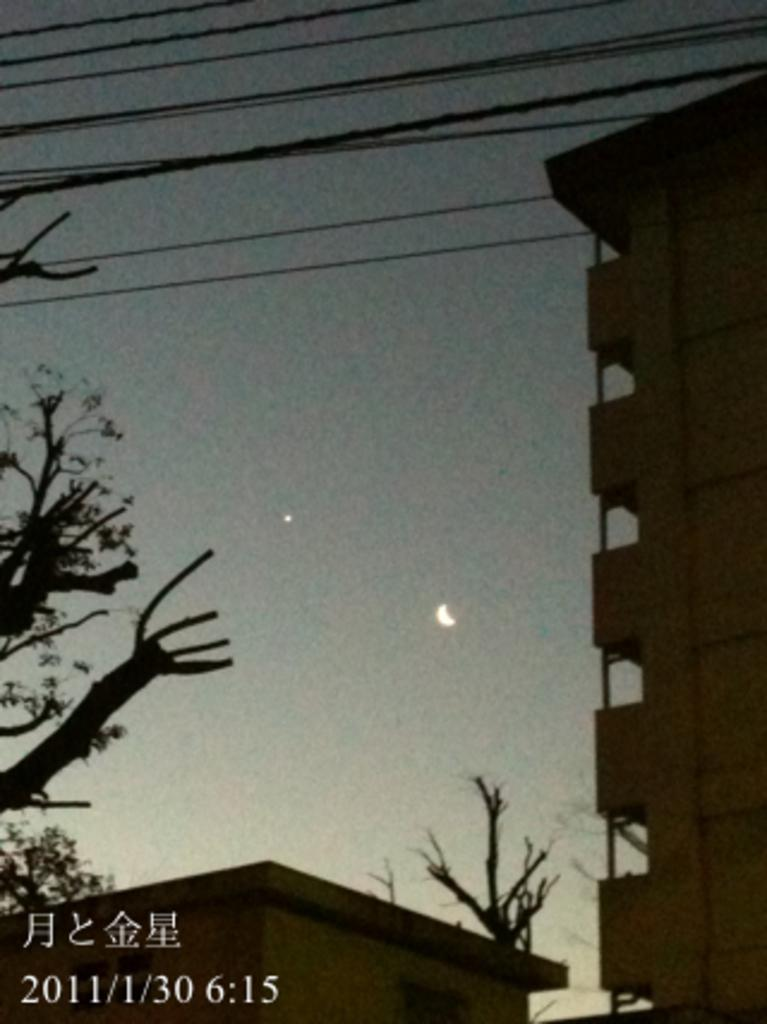What type of structure is present in the image? There is a building and a house in the image. What is located near the house? There are trees around the house. What can be seen above the trees? There are wires above the trees. What type of pain is the house experiencing in the image? The house is not experiencing any pain in the image, as pain is a sensation experienced by living beings and not applicable to inanimate objects like houses. 